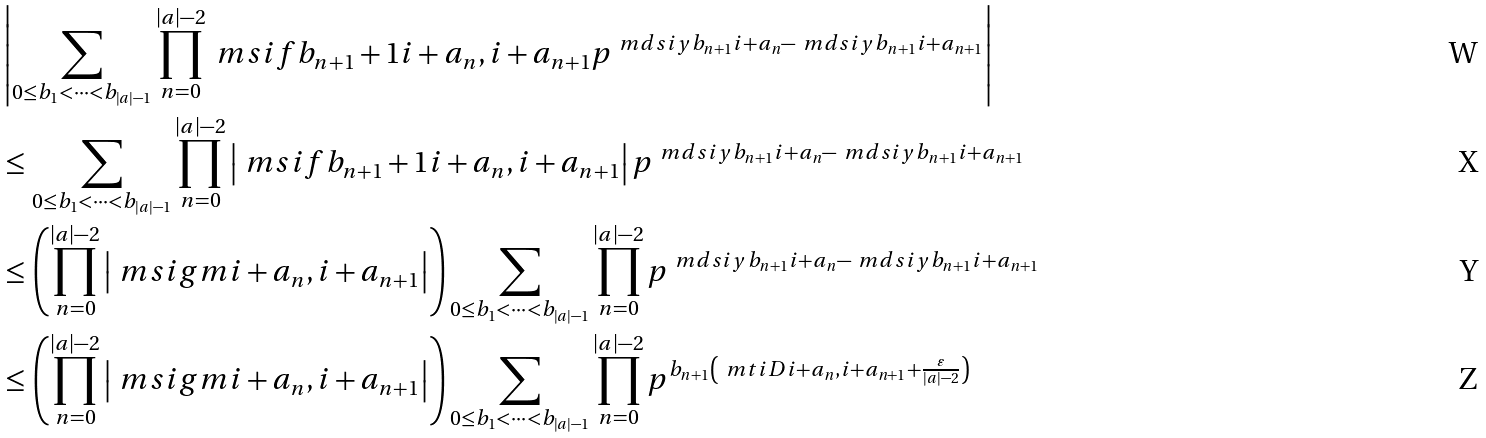Convert formula to latex. <formula><loc_0><loc_0><loc_500><loc_500>& \left | \sum _ { 0 \leq b _ { 1 } < \dots < b _ { \left | a \right | - 1 } } \prod _ { n = 0 } ^ { \left | a \right | - 2 } \ m s i { f } { b _ { n + 1 } + 1 } { i + a _ { n } , i + a _ { n + 1 } } p ^ { \ m d s i { y } { b _ { n + 1 } } { i + a _ { n } } - \ m d s i { y } { b _ { n + 1 } } { i + a _ { n + 1 } } } \right | \\ & \leq \sum _ { 0 \leq b _ { 1 } < \dots < b _ { \left | a \right | - 1 } } \prod _ { n = 0 } ^ { \left | a \right | - 2 } \left | \ m s i { f } { b _ { n + 1 } + 1 } { i + a _ { n } , i + a _ { n + 1 } } \right | p ^ { \ m d s i { y } { b _ { n + 1 } } { i + a _ { n } } - \ m d s i { y } { b _ { n + 1 } } { i + a _ { n + 1 } } } \\ & \leq \left ( \prod _ { n = 0 } ^ { \left | a \right | - 2 } \left | \ m s i { g } { m } { i + a _ { n } , i + a _ { n + 1 } } \right | \right ) \sum _ { 0 \leq b _ { 1 } < \dots < b _ { \left | a \right | - 1 } } \prod _ { n = 0 } ^ { \left | a \right | - 2 } p ^ { \ m d s i { y } { b _ { n + 1 } } { i + a _ { n } } - \ m d s i { y } { b _ { n + 1 } } { i + a _ { n + 1 } } } \\ & \leq \left ( \prod _ { n = 0 } ^ { \left | a \right | - 2 } \left | \ m s i { g } { m } { i + a _ { n } , i + a _ { n + 1 } } \right | \right ) \sum _ { 0 \leq b _ { 1 } < \dots < b _ { \left | a \right | - 1 } } \prod _ { n = 0 } ^ { \left | a \right | - 2 } p ^ { b _ { n + 1 } \left ( \ m t i { D } { i + a _ { n } , i + a _ { n + 1 } } + \frac { \varepsilon } { | a | - 2 } \right ) }</formula> 